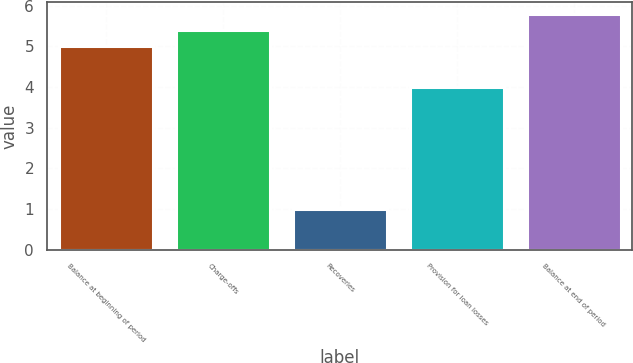<chart> <loc_0><loc_0><loc_500><loc_500><bar_chart><fcel>Balance at beginning of period<fcel>Charge-offs<fcel>Recoveries<fcel>Provision for loan losses<fcel>Balance at end of period<nl><fcel>5<fcel>5.4<fcel>1<fcel>4<fcel>5.8<nl></chart> 